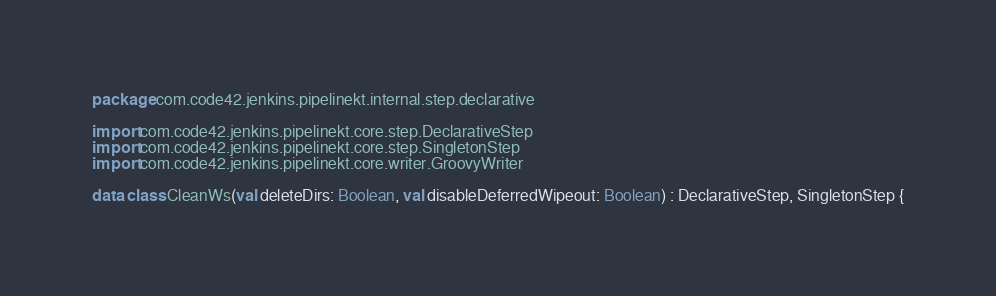<code> <loc_0><loc_0><loc_500><loc_500><_Kotlin_>package com.code42.jenkins.pipelinekt.internal.step.declarative

import com.code42.jenkins.pipelinekt.core.step.DeclarativeStep
import com.code42.jenkins.pipelinekt.core.step.SingletonStep
import com.code42.jenkins.pipelinekt.core.writer.GroovyWriter

data class CleanWs(val deleteDirs: Boolean, val disableDeferredWipeout: Boolean) : DeclarativeStep, SingletonStep {</code> 